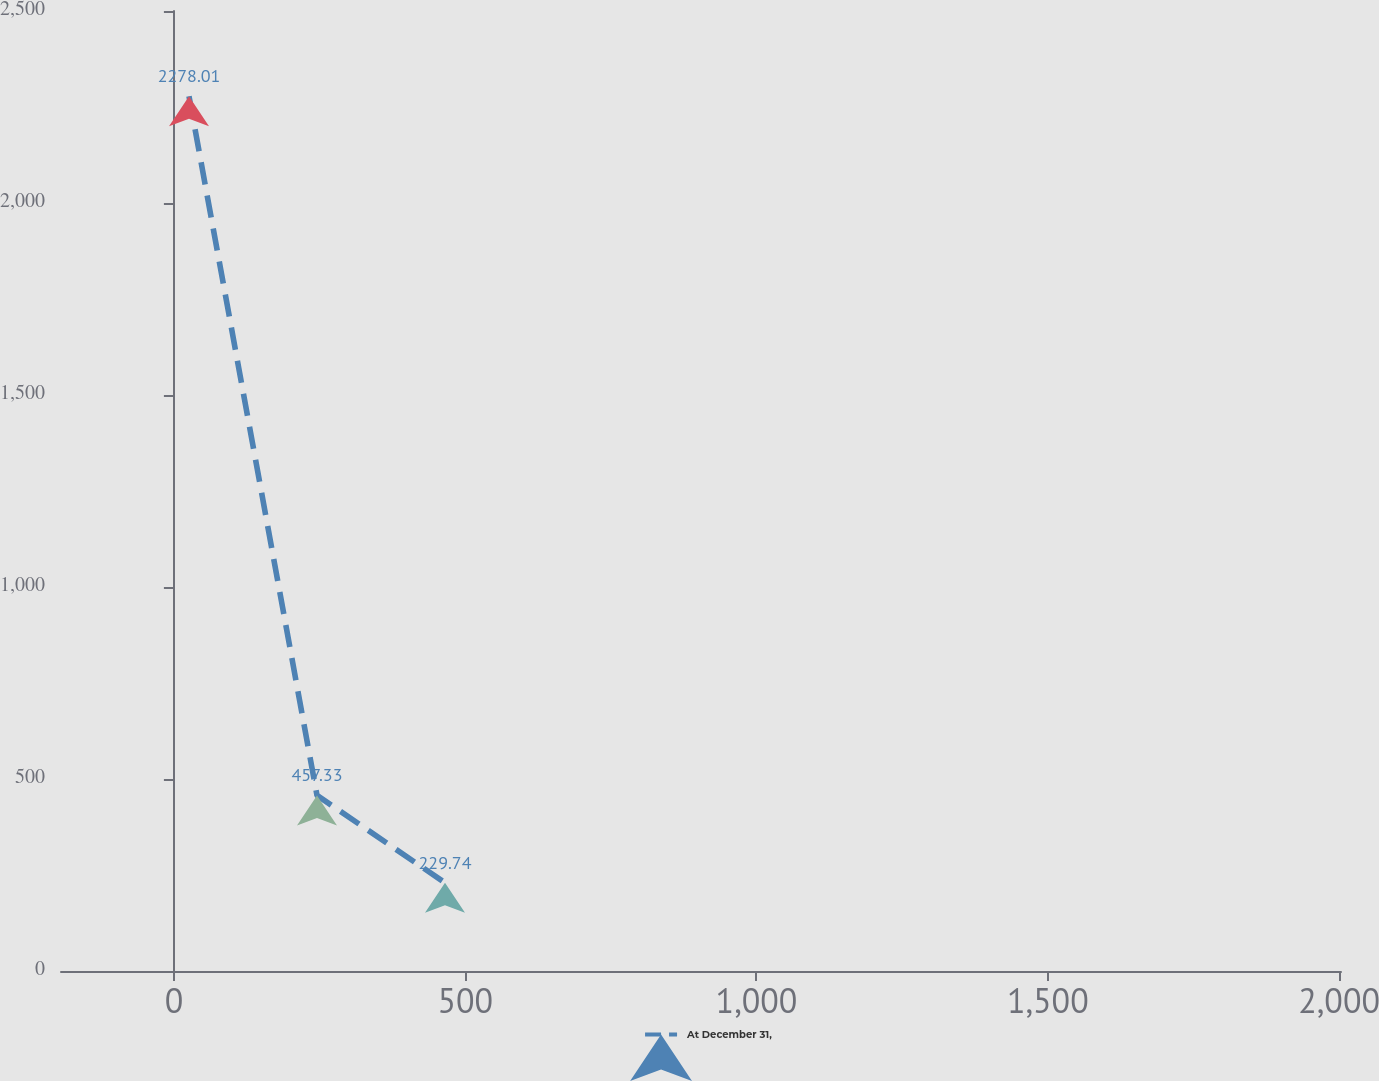<chart> <loc_0><loc_0><loc_500><loc_500><line_chart><ecel><fcel>At December 31,<nl><fcel>25.91<fcel>2278.01<nl><fcel>245.62<fcel>457.33<nl><fcel>465.33<fcel>229.74<nl><fcel>2223.02<fcel>2.15<nl></chart> 